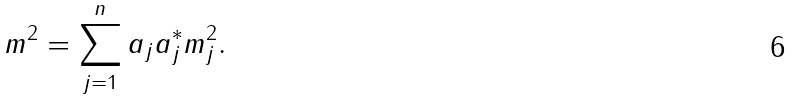<formula> <loc_0><loc_0><loc_500><loc_500>m ^ { 2 } = \sum _ { j = 1 } ^ { n } a _ { j } a _ { j } ^ { * } m _ { j } ^ { 2 } .</formula> 